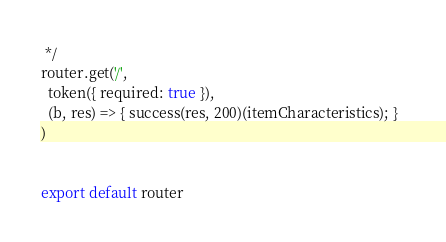Convert code to text. <code><loc_0><loc_0><loc_500><loc_500><_JavaScript_> */
router.get('/',
  token({ required: true }),
  (b, res) => { success(res, 200)(itemCharacteristics); }  
)


export default router
</code> 